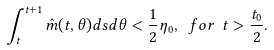Convert formula to latex. <formula><loc_0><loc_0><loc_500><loc_500>\int _ { t } ^ { t + 1 } \hat { m } ( t , \theta ) d s d \theta < \frac { 1 } { 2 } \eta _ { 0 } , \ f o r \ t > \frac { t _ { 0 } } { 2 } .</formula> 